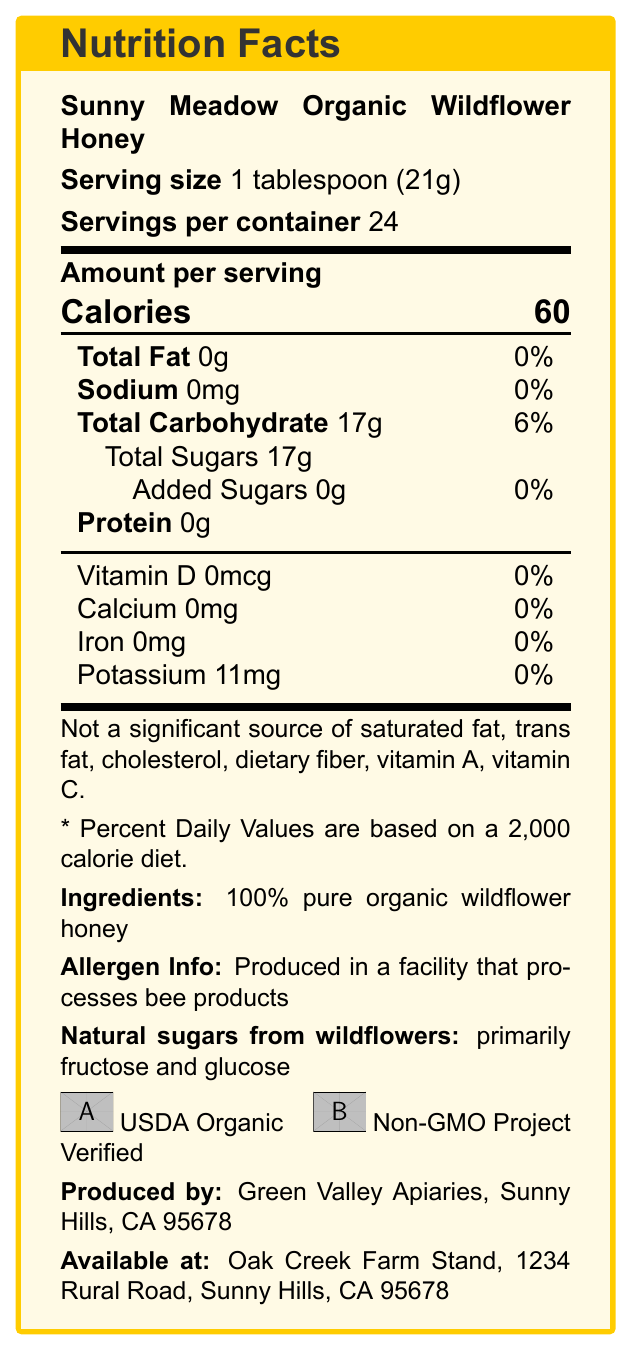what is the serving size of Sunny Meadow Organic Wildflower Honey? The document clearly states the serving size as "1 tablespoon (21g)".
Answer: 1 tablespoon (21g) how many calories are there per serving? The document lists the amount of calories per serving as 60.
Answer: 60 what is the total carbohydrate content per serving? The document indicates that the total carbohydrate content per serving is 17g.
Answer: 17g how much Total Sugars does it contain per serving? The document mentions that Total Sugars per serving is 17g.
Answer: 17g what is the source of sugars in the honey? The document specifies that the natural sugars from wildflowers are primarily fructose and glucose.
Answer: wildflowers, primarily fructose and glucose how many servings are there per container? The document states that there are 24 servings per container.
Answer: 24 What is the amount of added sugars in Sunny Meadow Organic Wildflower Honey? A. 0g B. 5g C. 10g D. 15g The document mentions that the amount of added sugars is 0g.
Answer: A. 0g What is the daily value percentage of sodium? A. 0% B. 5% C. 10% D. 15% The document lists the daily value percentage of sodium as 0%.
Answer: A. 0% Is there any significant source of vitamin C in this honey? The document explicitly states it is not a significant source of vitamin C.
Answer: No Describe the main components of the Nutrition Facts document for Sunny Meadow Organic Wildflower Honey. The document provides a detailed breakdown of both macronutrients and micronutrients along with additional information such as ingredients, allergen information, and certifications.
Answer: The document provides nutritional information for Sunny Meadow Organic Wildflower Honey, including serving size, calories, total fat, sodium, total carbohydrates, total sugars, and protein. It also lists vitamin D, calcium, iron, and potassium contents along with additional details like ingredients, allergen info, and certifications. What is the potassium content per serving? The document states that the potassium content per serving is 11mg.
Answer: 11mg Where is the honey produced? The producer information in the document indicates Green Valley Apiaries located in Sunny Hills, CA 95678.
Answer: Sunny Hills, CA 95678 what is the daily value percentage of Total Carbohydrate? The document provides the daily value percentage for Total Carbohydrate as 6%.
Answer: 6% How many grams of protein are in one serving of Sunny Meadow Organic Wildflower Honey? The document mentions that there is 0g of protein per serving.
Answer: 0g What certifications does the honey have? A. USDA Organic B. Non-GMO Project Verified C. Both A and B D. None The document includes both USDA Organic and Non-GMO Project Verified certifications.
Answer: C. Both A and B In what type of facility is this honey produced? The document mentions the allergen info which indicates it is produced in a facility that processes bee products.
Answer: Produced in a facility that processes bee products What is the farm stand name where the honey is available? The farm stand details in the document specify the name as Oak Creek Farm Stand.
Answer: Oak Creek Farm Stand What is the total fat content in this honey? The document indicates that the total fat content per serving is 0g.
Answer: 0g Is saturated fat listed in the nutrition facts? The document explicitly states that it is not a significant source of saturated fat.
Answer: No What type of diet are the Percent Daily Values based on? The document mentions that the Percent Daily Values are based on a 2,000 calorie diet.
Answer: 2,000 calorie diet How long has Green Valley Apiaries been in operation? The document does not provide any information regarding the operational history of Green Valley Apiaries.
Answer: Not enough information 